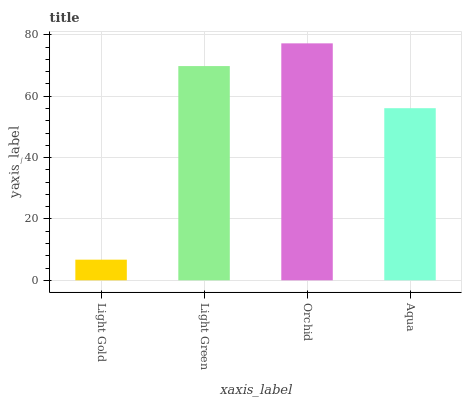Is Light Green the minimum?
Answer yes or no. No. Is Light Green the maximum?
Answer yes or no. No. Is Light Green greater than Light Gold?
Answer yes or no. Yes. Is Light Gold less than Light Green?
Answer yes or no. Yes. Is Light Gold greater than Light Green?
Answer yes or no. No. Is Light Green less than Light Gold?
Answer yes or no. No. Is Light Green the high median?
Answer yes or no. Yes. Is Aqua the low median?
Answer yes or no. Yes. Is Aqua the high median?
Answer yes or no. No. Is Light Green the low median?
Answer yes or no. No. 